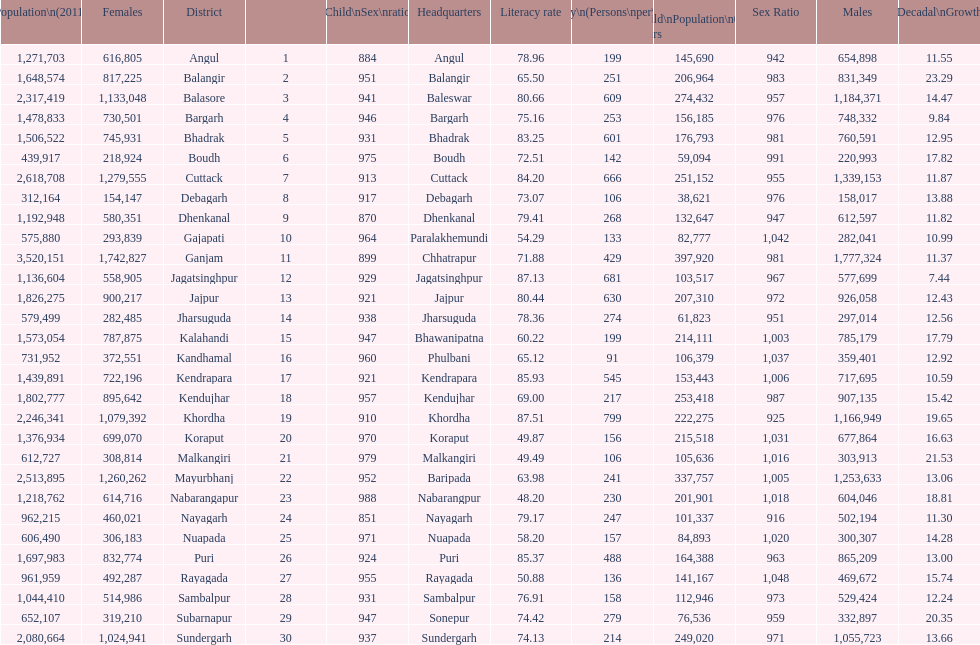Parse the full table. {'header': ['Population\\n(2011)', 'Females', 'District', '', 'Child\\nSex\\nratio', 'Headquarters', 'Literacy rate', 'Density\\n(Persons\\nper\\nkm2)', 'Child\\nPopulation\\n0–6 years', 'Sex Ratio', 'Males', 'Percentage\\nDecadal\\nGrowth\\n2001-2011'], 'rows': [['1,271,703', '616,805', 'Angul', '1', '884', 'Angul', '78.96', '199', '145,690', '942', '654,898', '11.55'], ['1,648,574', '817,225', 'Balangir', '2', '951', 'Balangir', '65.50', '251', '206,964', '983', '831,349', '23.29'], ['2,317,419', '1,133,048', 'Balasore', '3', '941', 'Baleswar', '80.66', '609', '274,432', '957', '1,184,371', '14.47'], ['1,478,833', '730,501', 'Bargarh', '4', '946', 'Bargarh', '75.16', '253', '156,185', '976', '748,332', '9.84'], ['1,506,522', '745,931', 'Bhadrak', '5', '931', 'Bhadrak', '83.25', '601', '176,793', '981', '760,591', '12.95'], ['439,917', '218,924', 'Boudh', '6', '975', 'Boudh', '72.51', '142', '59,094', '991', '220,993', '17.82'], ['2,618,708', '1,279,555', 'Cuttack', '7', '913', 'Cuttack', '84.20', '666', '251,152', '955', '1,339,153', '11.87'], ['312,164', '154,147', 'Debagarh', '8', '917', 'Debagarh', '73.07', '106', '38,621', '976', '158,017', '13.88'], ['1,192,948', '580,351', 'Dhenkanal', '9', '870', 'Dhenkanal', '79.41', '268', '132,647', '947', '612,597', '11.82'], ['575,880', '293,839', 'Gajapati', '10', '964', 'Paralakhemundi', '54.29', '133', '82,777', '1,042', '282,041', '10.99'], ['3,520,151', '1,742,827', 'Ganjam', '11', '899', 'Chhatrapur', '71.88', '429', '397,920', '981', '1,777,324', '11.37'], ['1,136,604', '558,905', 'Jagatsinghpur', '12', '929', 'Jagatsinghpur', '87.13', '681', '103,517', '967', '577,699', '7.44'], ['1,826,275', '900,217', 'Jajpur', '13', '921', 'Jajpur', '80.44', '630', '207,310', '972', '926,058', '12.43'], ['579,499', '282,485', 'Jharsuguda', '14', '938', 'Jharsuguda', '78.36', '274', '61,823', '951', '297,014', '12.56'], ['1,573,054', '787,875', 'Kalahandi', '15', '947', 'Bhawanipatna', '60.22', '199', '214,111', '1,003', '785,179', '17.79'], ['731,952', '372,551', 'Kandhamal', '16', '960', 'Phulbani', '65.12', '91', '106,379', '1,037', '359,401', '12.92'], ['1,439,891', '722,196', 'Kendrapara', '17', '921', 'Kendrapara', '85.93', '545', '153,443', '1,006', '717,695', '10.59'], ['1,802,777', '895,642', 'Kendujhar', '18', '957', 'Kendujhar', '69.00', '217', '253,418', '987', '907,135', '15.42'], ['2,246,341', '1,079,392', 'Khordha', '19', '910', 'Khordha', '87.51', '799', '222,275', '925', '1,166,949', '19.65'], ['1,376,934', '699,070', 'Koraput', '20', '970', 'Koraput', '49.87', '156', '215,518', '1,031', '677,864', '16.63'], ['612,727', '308,814', 'Malkangiri', '21', '979', 'Malkangiri', '49.49', '106', '105,636', '1,016', '303,913', '21.53'], ['2,513,895', '1,260,262', 'Mayurbhanj', '22', '952', 'Baripada', '63.98', '241', '337,757', '1,005', '1,253,633', '13.06'], ['1,218,762', '614,716', 'Nabarangapur', '23', '988', 'Nabarangpur', '48.20', '230', '201,901', '1,018', '604,046', '18.81'], ['962,215', '460,021', 'Nayagarh', '24', '851', 'Nayagarh', '79.17', '247', '101,337', '916', '502,194', '11.30'], ['606,490', '306,183', 'Nuapada', '25', '971', 'Nuapada', '58.20', '157', '84,893', '1,020', '300,307', '14.28'], ['1,697,983', '832,774', 'Puri', '26', '924', 'Puri', '85.37', '488', '164,388', '963', '865,209', '13.00'], ['961,959', '492,287', 'Rayagada', '27', '955', 'Rayagada', '50.88', '136', '141,167', '1,048', '469,672', '15.74'], ['1,044,410', '514,986', 'Sambalpur', '28', '931', 'Sambalpur', '76.91', '158', '112,946', '973', '529,424', '12.24'], ['652,107', '319,210', 'Subarnapur', '29', '947', 'Sonepur', '74.42', '279', '76,536', '959', '332,897', '20.35'], ['2,080,664', '1,024,941', 'Sundergarh', '30', '937', 'Sundergarh', '74.13', '214', '249,020', '971', '1,055,723', '13.66']]} Tell me a district that did not have a population over 600,000. Boudh. 